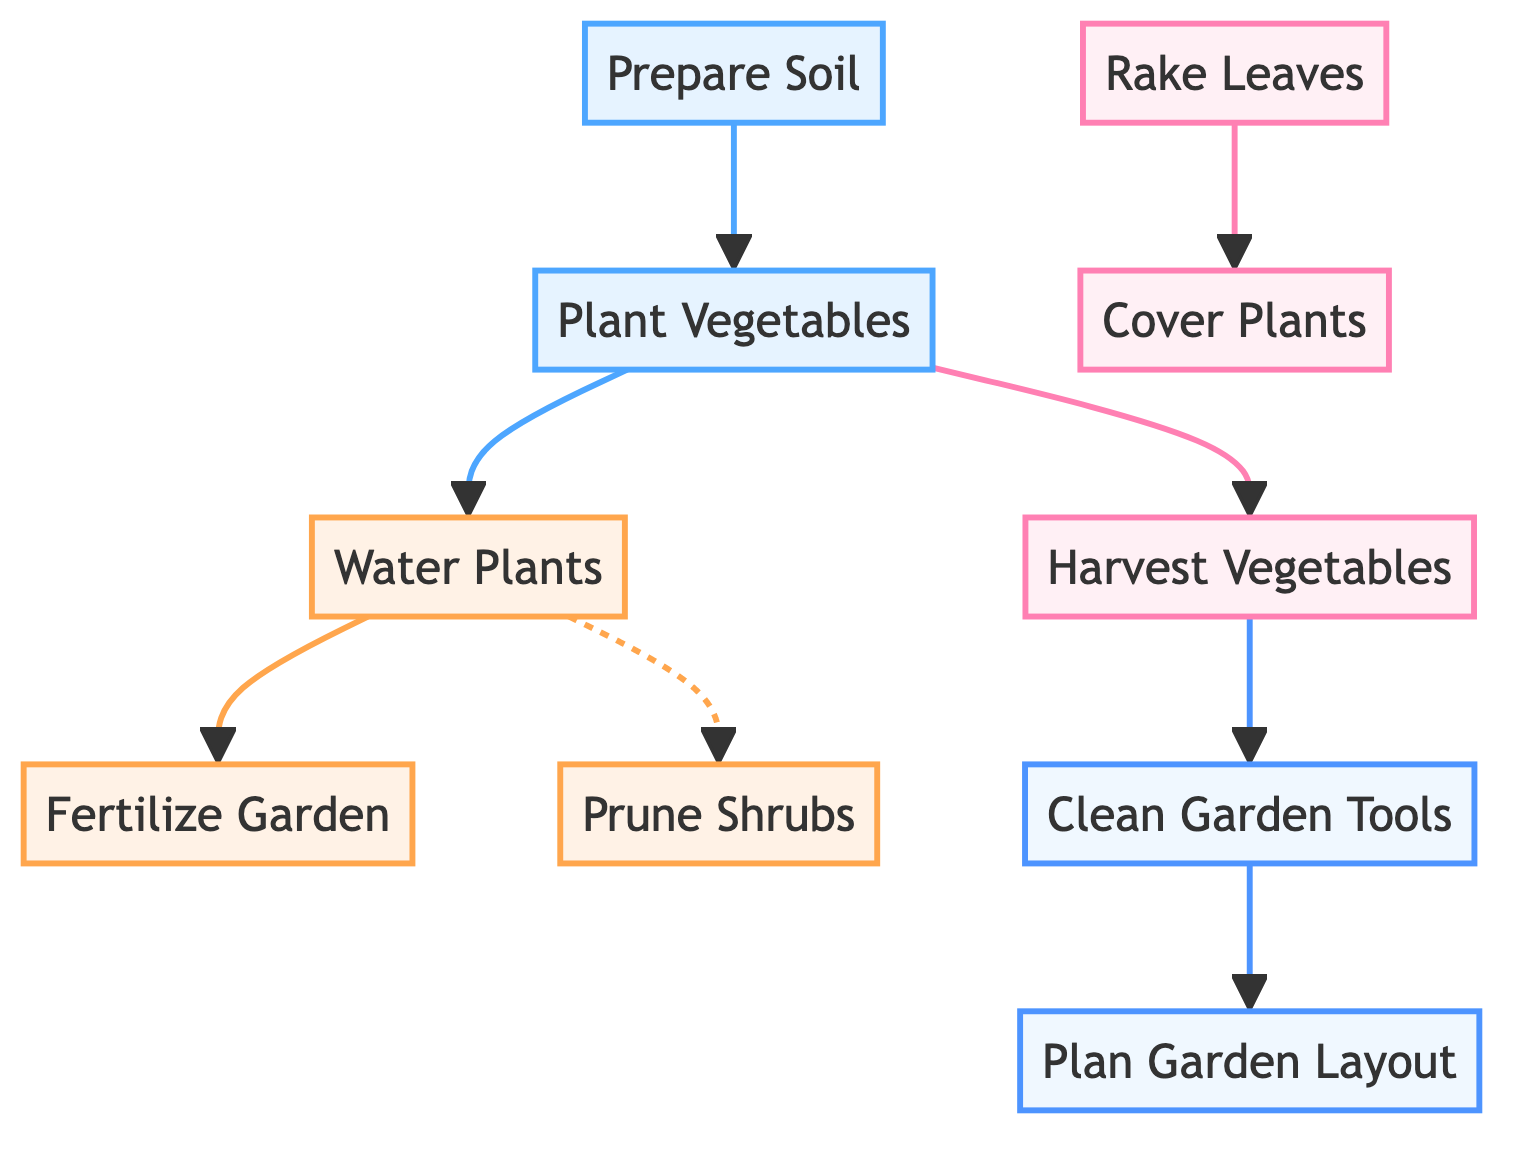What is the first task in the schedule? The diagram starts with the node "Prepare Soil," which indicates it is the first task to be completed in the garden maintenance schedule.
Answer: Prepare Soil How many nodes are in the diagram? Counting all unique tasks represented as nodes, there are 10 distinct nodes in total.
Answer: 10 What task follows "Harvest Vegetables"? According to the edges, after "Harvest Vegetables," the next task to be done is "Clean Garden Tools."
Answer: Clean Garden Tools Which tasks occur in summer? The tasks listed under the summer season include "Water Plants," "Fertilize Garden," and "Prune Shrubs."
Answer: Water Plants, Fertilize Garden, Prune Shrubs What is needed before "Plant Vegetables"? The edge from "Prepare Soil" to "Plant Vegetables" indicates that "Prepare Soil" is a prerequisite that needs to be completed beforehand.
Answer: Prepare Soil Are "Water Plants" and "Prune Shrubs" performed in the same season? Yes, both tasks occur during the summer season as indicated by the diagram.
Answer: Yes What leads to "Clean Garden Tools"? The task "Harvest Vegetables" is the leading task that results in the need to clean the garden tools afterward.
Answer: Harvest Vegetables What is the last task in the diagram? The final task is "Plan Garden Layout," which follows after cleaning the garden tools.
Answer: Plan Garden Layout What is the relationship between "Rake Leaves" and "Cover Plants"? According to the diagram, "Rake Leaves" precedes "Cover Plants," meaning it is done first before covering the plants.
Answer: precedes 